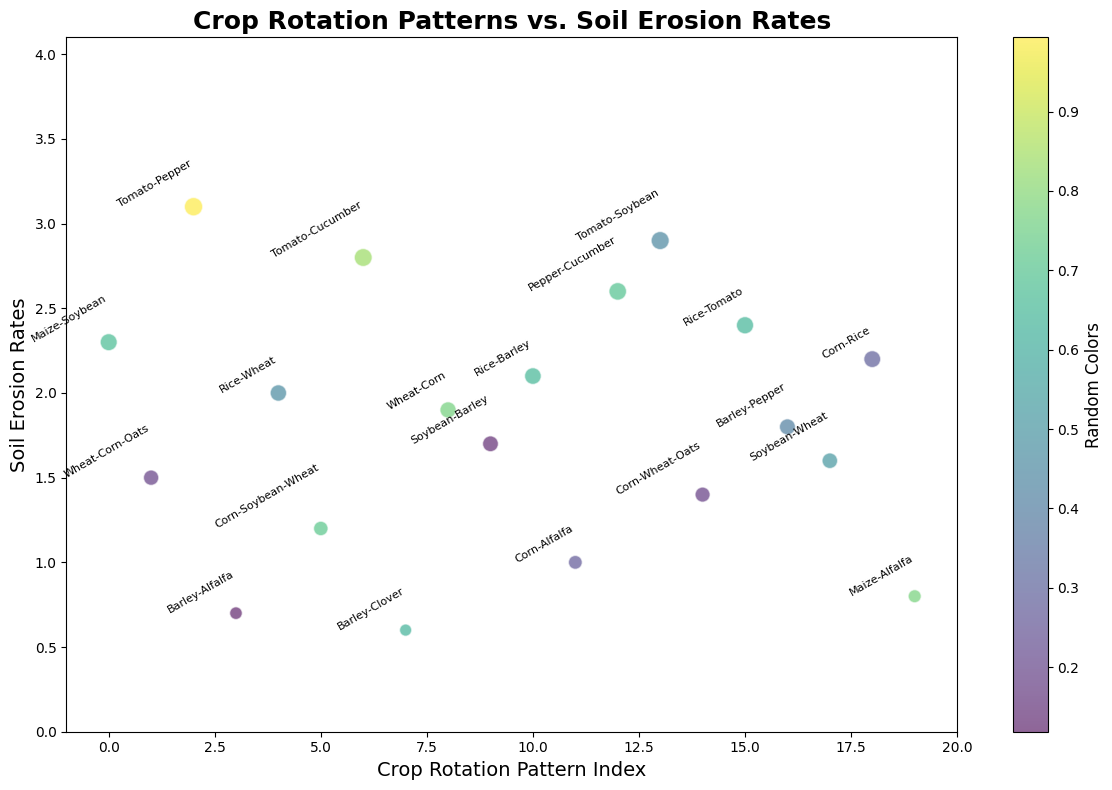Which crop rotation pattern has the lowest soil erosion rate? By looking at the scatter plot, the data point corresponding to the lowest y-value (soil erosion rate) is identified. The label associated with this point indicates the crop rotation pattern.
Answer: Barley-Clover Which crop rotation pattern is associated with a soil erosion rate of 2.4? Find the data point in the scatter plot corresponding to a y-value of 2.4 and identify the label of that point.
Answer: Rice-Tomato What is the average soil erosion rate for these crop rotation patterns? Sum all the soil erosion rates and divide by the number of data points. Sum: 2.3 + 1.5 + 3.1 + 0.7 + 2.0 + 1.2 + 2.8 + 0.6 + 1.9 + 1.7 + 2.1 + 1.0 + 2.6 + 2.9 + 1.4 + 2.4 + 1.8 + 1.6 + 2.2 + 0.8 = 40.9, Number of data points: 20. Average: 40.9 / 20 = 2.045
Answer: 2.045 Which two crop rotation patterns have the smallest difference in their soil erosion rates? Calculate the differences between the soil erosion rates for all possible pairs of crop rotation patterns, identify the pair with the smallest difference.
Answer: Wheat-Corn and Rice-Wheat (difference of 0.1) Are there more crop rotation patterns with soil erosion rates higher or lower than 2.0? Count the data points with soil erosion rates higher than 2.0 and those with rates lower than 2.0. Compare the counts. Higher: 9 (2.3, 3.1, 2.0, 2.8, 2.1, 2.6, 2.9, 2.4, 2.2). Lower: 11 (1.5, 0.7, 1.2, 0.6, 1.9, 1.7, 1.0, 1.4, 1.8, 1.6, 0.8).
Answer: Lower Which crop rotation patterns have soil erosion rates within 0.1 units of 1.5? Identify data points with y-values between 1.4 and 1.6, then check their labels.
Answer: Soybean-Wheat and Corn-Wheat-Oats Which crop rotation pattern is closest to the soil erosion rate of 1.0 but not exactly 1.0? Identify the data points with soil erosion rates close to 1.0 but not 1.0, then find the closest.
Answer: Corn-Alfalfa (next highest is Wheat-Corn-Oats at 1.4) How many crop rotation patterns have soil erosion rates less than 1.0? Count the data points where soil erosion rates (y-values) are less than 1.0.
Answer: 3 (Barley-Alfalfa, Barley-Clover, Maize-Alfalfa) What is the range of the soil erosion rates? Subtract the lowest soil erosion rate from the highest soil erosion rate. Highest rate: 3.1. Lowest rate: 0.6. Range: 3.1 - 0.6 = 2.5
Answer: 2.5 